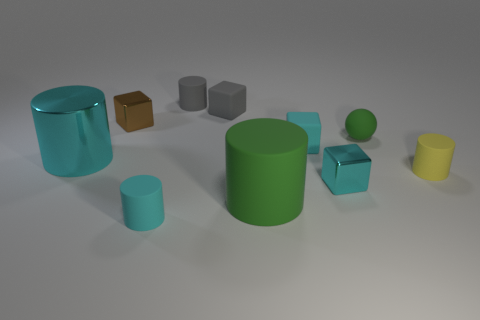What is the size of the object that is to the left of the block to the left of the matte cylinder left of the gray cylinder?
Your answer should be very brief. Large. What size is the gray object that is the same shape as the yellow rubber object?
Offer a very short reply. Small. How many small gray cubes are on the right side of the small cyan matte cube?
Offer a terse response. 0. There is a small cylinder behind the tiny matte sphere; does it have the same color as the small sphere?
Your response must be concise. No. How many red things are big objects or metallic blocks?
Offer a terse response. 0. There is a matte cube that is to the left of the tiny cyan cube that is behind the small yellow object; what color is it?
Make the answer very short. Gray. What material is the tiny cylinder that is the same color as the big metallic cylinder?
Your answer should be compact. Rubber. There is a rubber cylinder behind the matte sphere; what color is it?
Your answer should be compact. Gray. Does the metallic thing to the right of the brown block have the same size as the cyan rubber cylinder?
Your answer should be very brief. Yes. What size is the matte object that is the same color as the sphere?
Your answer should be compact. Large. 